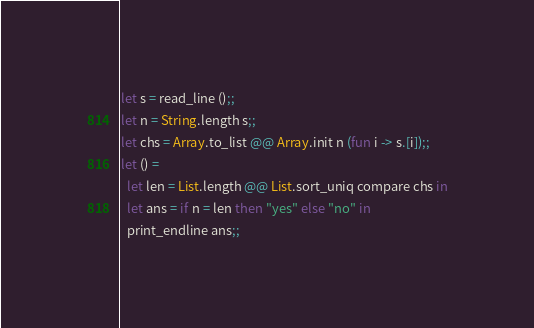Convert code to text. <code><loc_0><loc_0><loc_500><loc_500><_OCaml_>let s = read_line ();;
let n = String.length s;;
let chs = Array.to_list @@ Array.init n (fun i -> s.[i]);;
let () =
  let len = List.length @@ List.sort_uniq compare chs in
  let ans = if n = len then "yes" else "no" in
  print_endline ans;;
</code> 